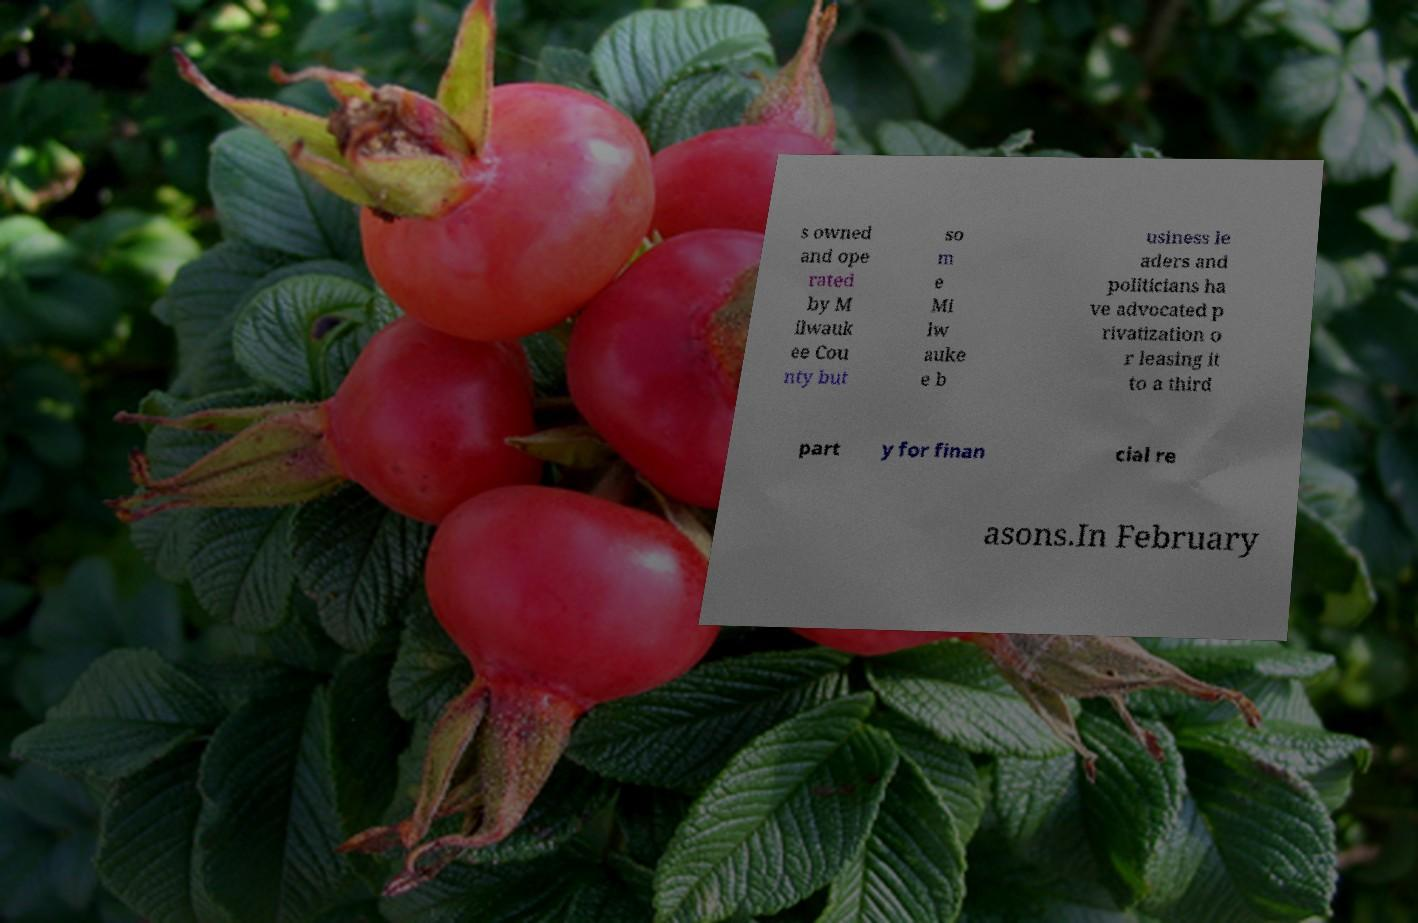Could you assist in decoding the text presented in this image and type it out clearly? s owned and ope rated by M ilwauk ee Cou nty but so m e Mi lw auke e b usiness le aders and politicians ha ve advocated p rivatization o r leasing it to a third part y for finan cial re asons.In February 